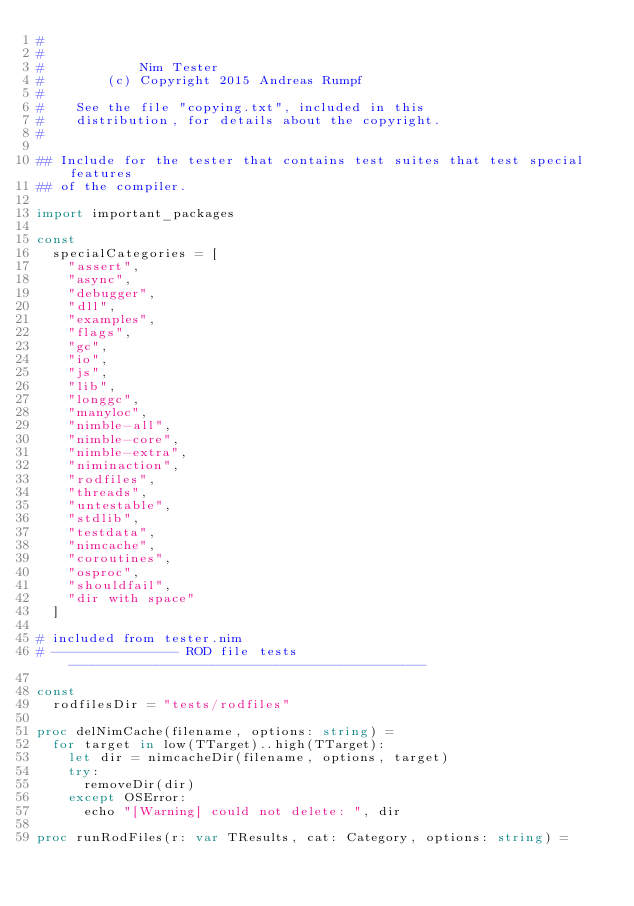Convert code to text. <code><loc_0><loc_0><loc_500><loc_500><_Nim_>#
#
#            Nim Tester
#        (c) Copyright 2015 Andreas Rumpf
#
#    See the file "copying.txt", included in this
#    distribution, for details about the copyright.
#

## Include for the tester that contains test suites that test special features
## of the compiler.

import important_packages

const
  specialCategories = [
    "assert",
    "async",
    "debugger",
    "dll",
    "examples",
    "flags",
    "gc",
    "io",
    "js",
    "lib",
    "longgc",
    "manyloc",
    "nimble-all",
    "nimble-core",
    "nimble-extra",
    "niminaction",
    "rodfiles",
    "threads",
    "untestable",
    "stdlib",
    "testdata",
    "nimcache",
    "coroutines",
    "osproc",
    "shouldfail",
    "dir with space"
  ]

# included from tester.nim
# ---------------- ROD file tests ---------------------------------------------

const
  rodfilesDir = "tests/rodfiles"

proc delNimCache(filename, options: string) =
  for target in low(TTarget)..high(TTarget):
    let dir = nimcacheDir(filename, options, target)
    try:
      removeDir(dir)
    except OSError:
      echo "[Warning] could not delete: ", dir

proc runRodFiles(r: var TResults, cat: Category, options: string) =</code> 